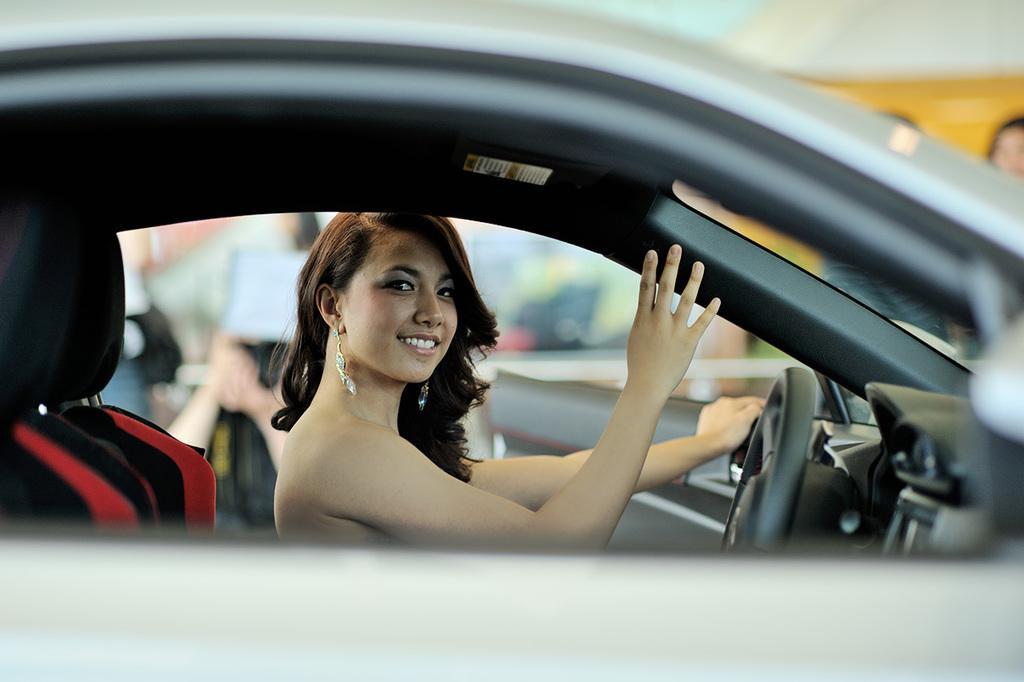Could you give a brief overview of what you see in this image? In this image, we can see women is inside the car. She is smiling. Here we can see steering. On left side, there is a seat. Back Side, we can see few peoples are standing here. Here we can see cream and white color. There is a door here. 